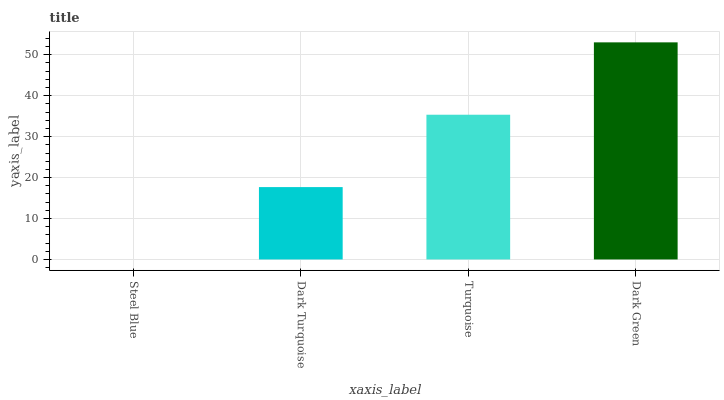Is Dark Turquoise the minimum?
Answer yes or no. No. Is Dark Turquoise the maximum?
Answer yes or no. No. Is Dark Turquoise greater than Steel Blue?
Answer yes or no. Yes. Is Steel Blue less than Dark Turquoise?
Answer yes or no. Yes. Is Steel Blue greater than Dark Turquoise?
Answer yes or no. No. Is Dark Turquoise less than Steel Blue?
Answer yes or no. No. Is Turquoise the high median?
Answer yes or no. Yes. Is Dark Turquoise the low median?
Answer yes or no. Yes. Is Dark Turquoise the high median?
Answer yes or no. No. Is Steel Blue the low median?
Answer yes or no. No. 